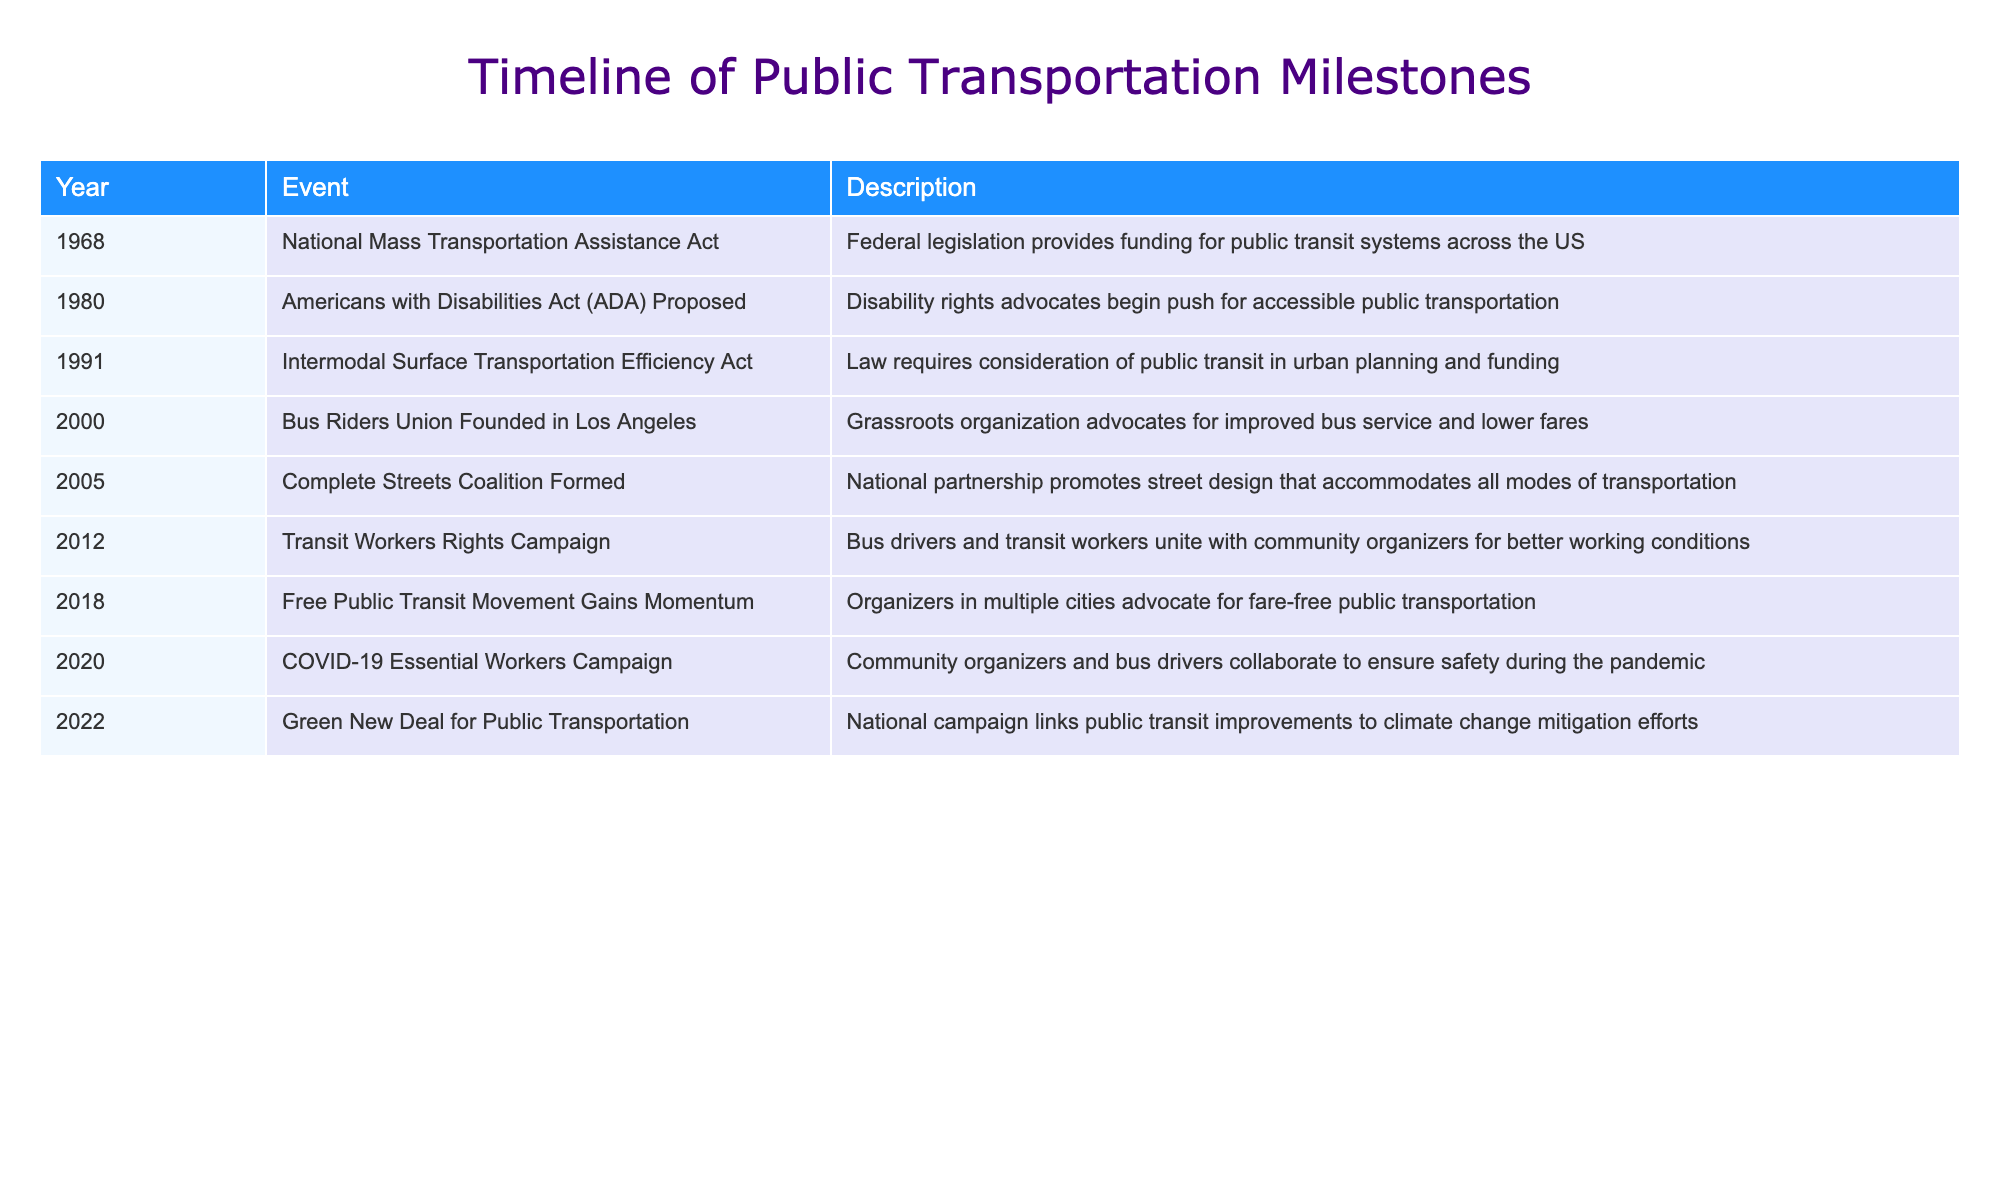What year was the Americans with Disabilities Act proposed? The table shows the event related to the Americans with Disabilities Act proposed in 1980. This information is located in the "Year" column corresponding to the respective event.
Answer: 1980 What event occurred immediately after the founding of the Bus Riders Union? The Bus Riders Union was founded in 2000, and the next event in the table is the formation of the Complete Streets Coalition in 2005. Thus, the event that occurred immediately after is the Complete Streets Coalition Formed.
Answer: Complete Streets Coalition Formed True or false: The Green New Deal for Public Transportation was linked to climate change mitigation. The description for the Green New Deal for Public Transportation states that it links public transit improvements to climate change mitigation efforts. Therefore, the statement is true.
Answer: True How many years passed between the National Mass Transportation Assistance Act and the Americans with Disabilities Act proposal? The National Mass Transportation Assistance Act occurred in 1968 and the Americans with Disabilities Act was proposed in 1980. To find the number of years between them, we calculate 1980 - 1968 = 12 years.
Answer: 12 What is the earliest event that emphasizes accessibility in transportation? Looking at the table, the earliest event that emphasizes accessibility is the Americans with Disabilities Act proposed in 1980. This is identifiable in the description indicating a push for accessible public transportation.
Answer: Americans with Disabilities Act Proposed What event marks the beginning of a collaboration between bus drivers and community organizers? The table indicates that the Transit Workers Rights Campaign in 2012 marks the collaboration between bus drivers and community organizers for better working conditions. This can be determined by referring to the description in that row.
Answer: Transit Workers Rights Campaign How many events in the timeline focus specifically on public transportation accessibility? From the table, two events specifically focus on accessibility: the Americans with Disabilities Act proposed and the Free Public Transit Movement Gains Momentum. Counting them gives a total of 2 events.
Answer: 2 Which milestone in community organizing highlights the collaboration of essential workers during a pandemic? The COVID-19 Essential Workers Campaign in 2020 is highlighted in the table as a milestone focusing on the collaboration of community organizers and bus drivers to ensure safety during the pandemic.
Answer: COVID-19 Essential Workers Campaign What is the trend in community organizing efforts from 2000 to 2022 regarding public transportation? Reviewing the events listed, from 2000 to 2022, there is a noticeable trend of increased focus on community organizing efforts aimed at improving public transportation, particularly with movements addressing fare-free transit, worker rights, and climate change. This indicates a growing recognition of public transportation as a critical component of community advocacy.
Answer: Increased focus on improving public transportation 